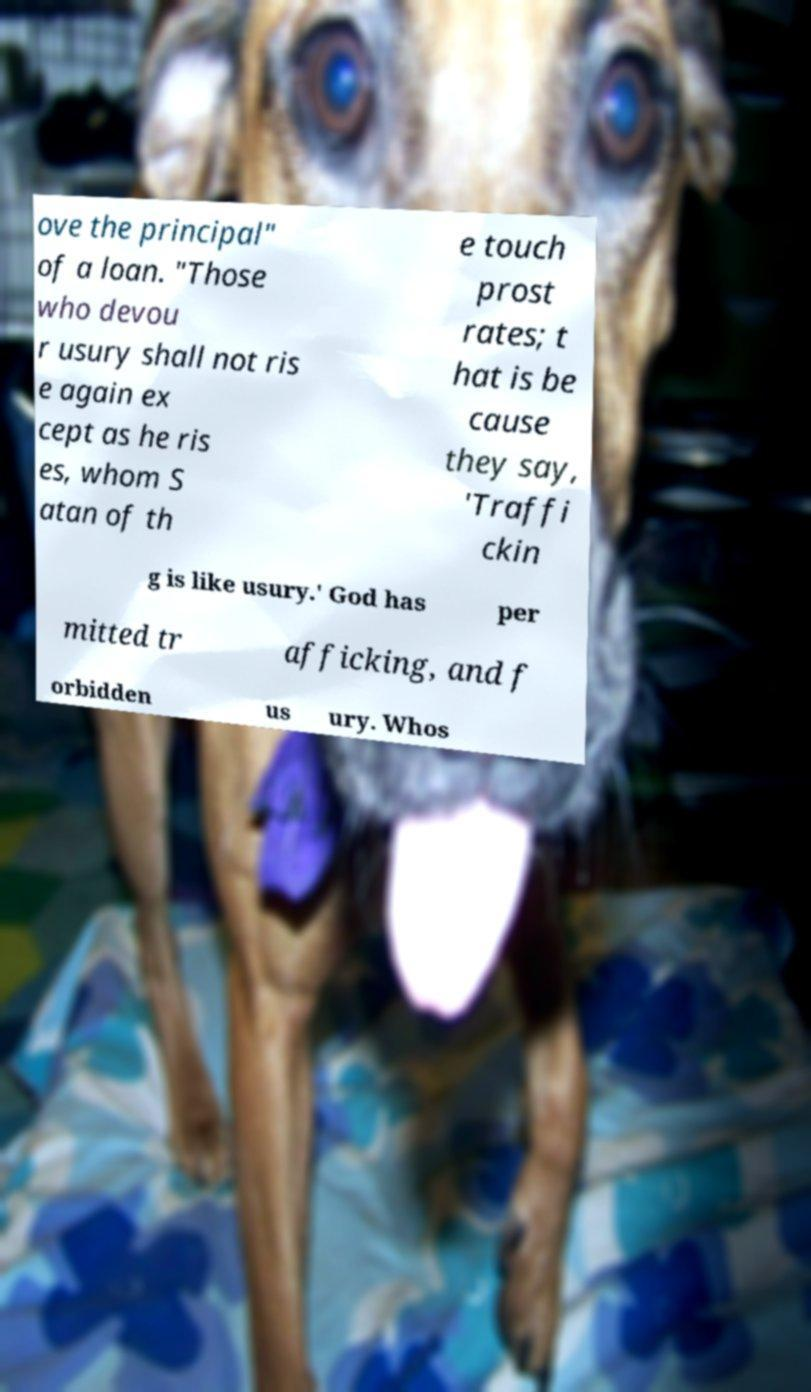I need the written content from this picture converted into text. Can you do that? ove the principal" of a loan. "Those who devou r usury shall not ris e again ex cept as he ris es, whom S atan of th e touch prost rates; t hat is be cause they say, 'Traffi ckin g is like usury.' God has per mitted tr afficking, and f orbidden us ury. Whos 